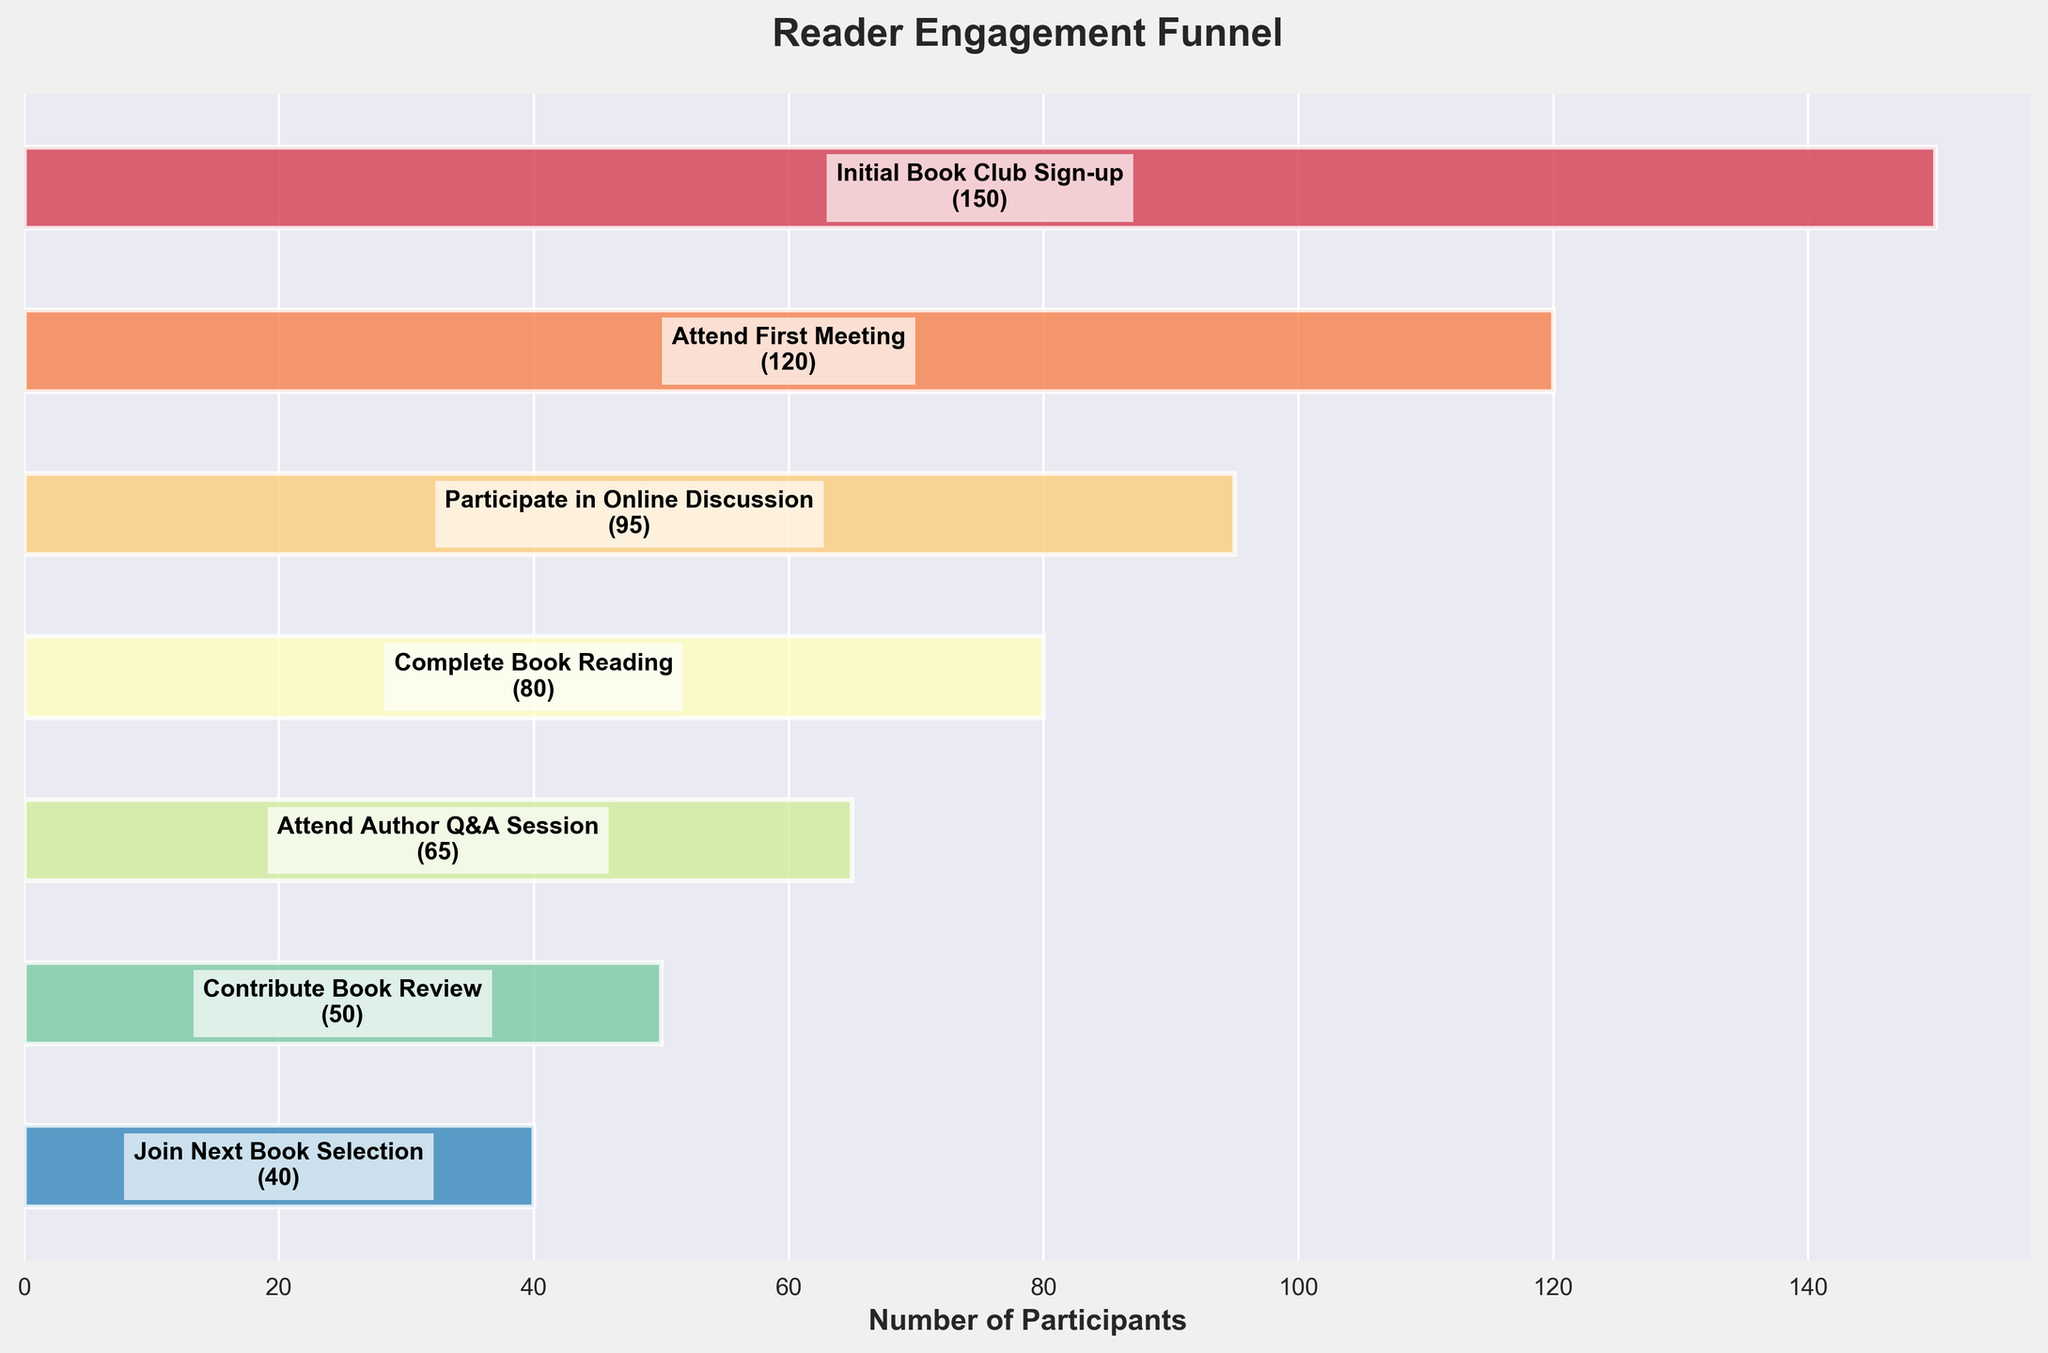What's the title of the chart? The title is located at the top of the figure, typically in a bold font and larger size to distinguish it from other elements. It reads, "Reader Engagement Funnel".
Answer: Reader Engagement Funnel What's the total number of participants who joined the initial book club sign-up? The initial stage labeled "Initial Book Club Sign-up" is marked with the number of participants, which is mentioned in the data related to the figure.
Answer: 150 What’s the difference in participant numbers between those who attended the first meeting and those who completed the book reading? To find the difference, subtract the number of those who completed the book reading (80) from those who attended the first meeting (120). The difference is calculated as 120 - 80 = 40.
Answer: 40 What stage had the highest drop in participants and by how much? By examining sequential participant numbers, the largest difference appears between "Attend First Meeting" (120) and "Participate in Online Discussion" (95). The drop is 120 - 95 = 25 participants.
Answer: Attend First Meeting to Participate in Online Discussion, 25 What’s the percentage of participants who completed the book reading compared to those who signed up initially? Compute the percentage by dividing the number of participants who completed the book reading (80) by the initial sign-ups (150) and then multiplying by 100. Hence, (80 / 150) * 100 = 53.33%.
Answer: 53.33% Which stage immediately follows participating in online discussions? Review the labeled data points in the sequence; the stage that immediately follows "Participate in Online Discussion" is "Complete Book Reading".
Answer: Complete Book Reading How many participants attended the Author Q&A Session? Locate the stage labeled "Attend Author Q&A Session" in the chart, which shows the corresponding number of participants.
Answer: 65 What's the ratio of participants who completed the book reading to those who joined the next book selection? The number of participants at the "Complete Book Reading" stage is 80 and those who joined the next book selection are 40. The ratio is calculated as 80 / 40 = 2.
Answer: 2 Which stage observes the lowest number of participants? By examining the data points visualized in the funnel chart, the stage "Join Next Book Selection" displays the lowest participant count, which is 40.
Answer: Join Next Book Selection 